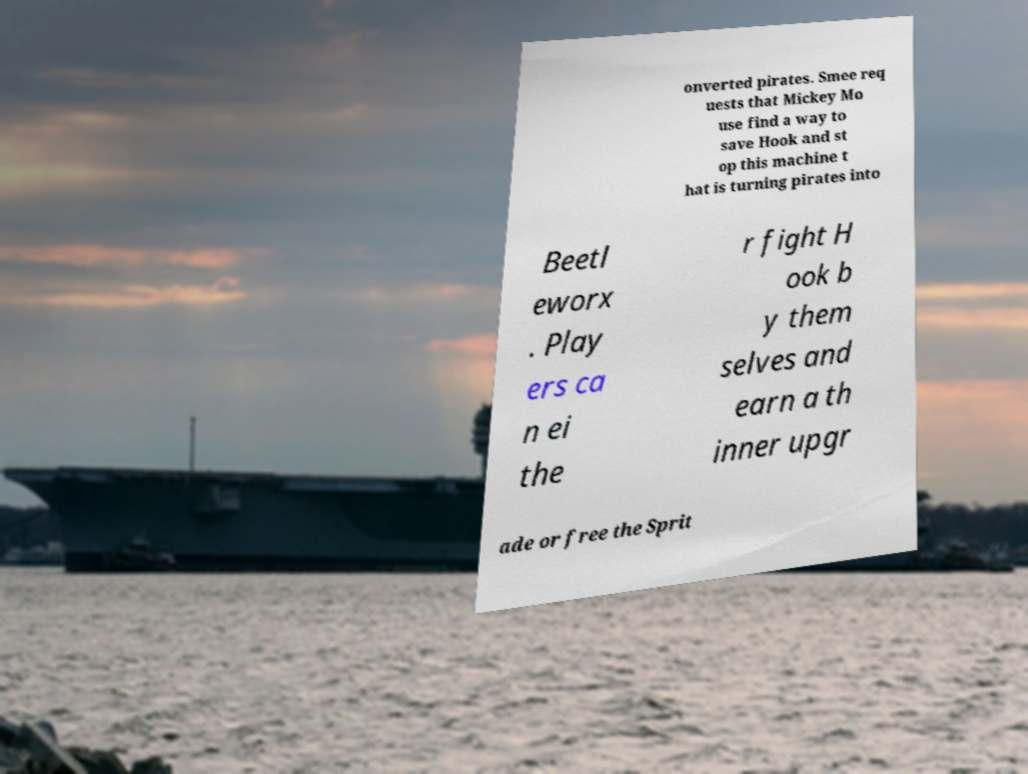Could you extract and type out the text from this image? onverted pirates. Smee req uests that Mickey Mo use find a way to save Hook and st op this machine t hat is turning pirates into Beetl eworx . Play ers ca n ei the r fight H ook b y them selves and earn a th inner upgr ade or free the Sprit 